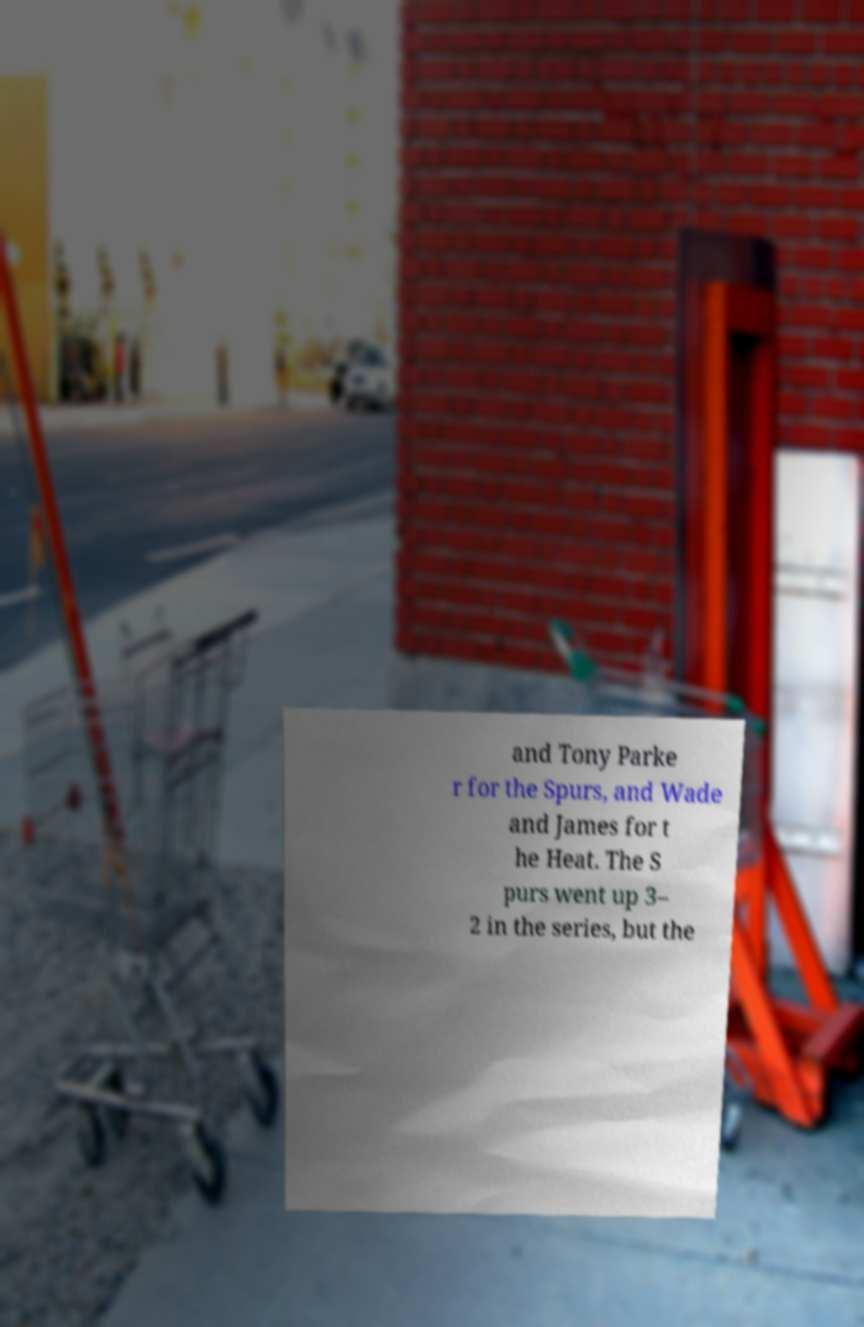Please read and relay the text visible in this image. What does it say? and Tony Parke r for the Spurs, and Wade and James for t he Heat. The S purs went up 3– 2 in the series, but the 